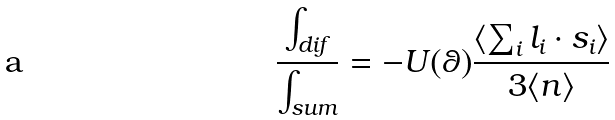Convert formula to latex. <formula><loc_0><loc_0><loc_500><loc_500>\frac { \int _ { d i f } } { \int _ { s u m } } = - U ( \theta ) \frac { \langle \sum _ { i } l _ { i } \cdot s _ { i } \rangle } { 3 \langle n \rangle }</formula> 